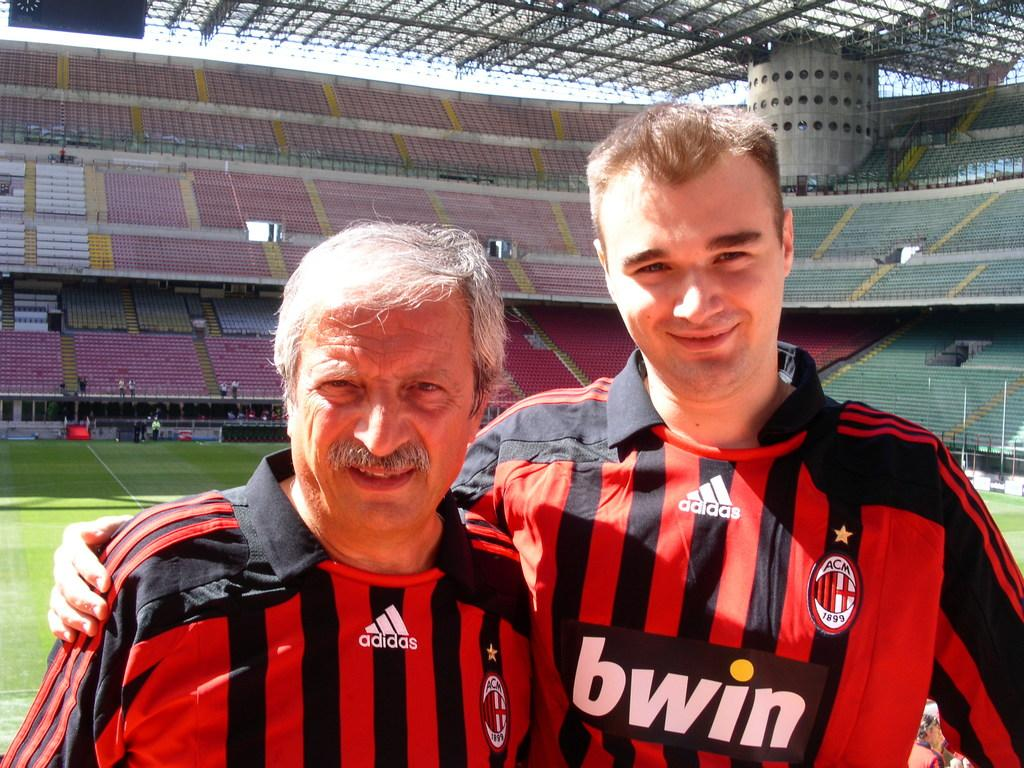<image>
Give a short and clear explanation of the subsequent image. Athlete wearing a jersey with Adidas in white on the front of the shirt. 